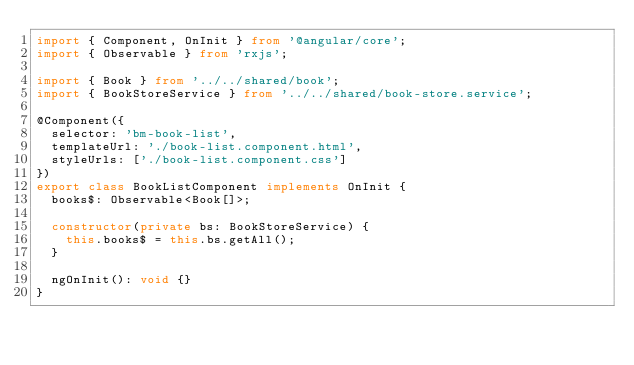Convert code to text. <code><loc_0><loc_0><loc_500><loc_500><_TypeScript_>import { Component, OnInit } from '@angular/core';
import { Observable } from 'rxjs';

import { Book } from '../../shared/book';
import { BookStoreService } from '../../shared/book-store.service';

@Component({
  selector: 'bm-book-list',
  templateUrl: './book-list.component.html',
  styleUrls: ['./book-list.component.css']
})
export class BookListComponent implements OnInit {
  books$: Observable<Book[]>;

  constructor(private bs: BookStoreService) {
    this.books$ = this.bs.getAll();
  }

  ngOnInit(): void {}
}
</code> 